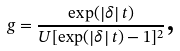<formula> <loc_0><loc_0><loc_500><loc_500>g = \frac { \exp ( \left | \delta \right | t ) } { U [ \exp ( \left | \delta \right | t ) - 1 ] ^ { 2 } } \text {,}</formula> 